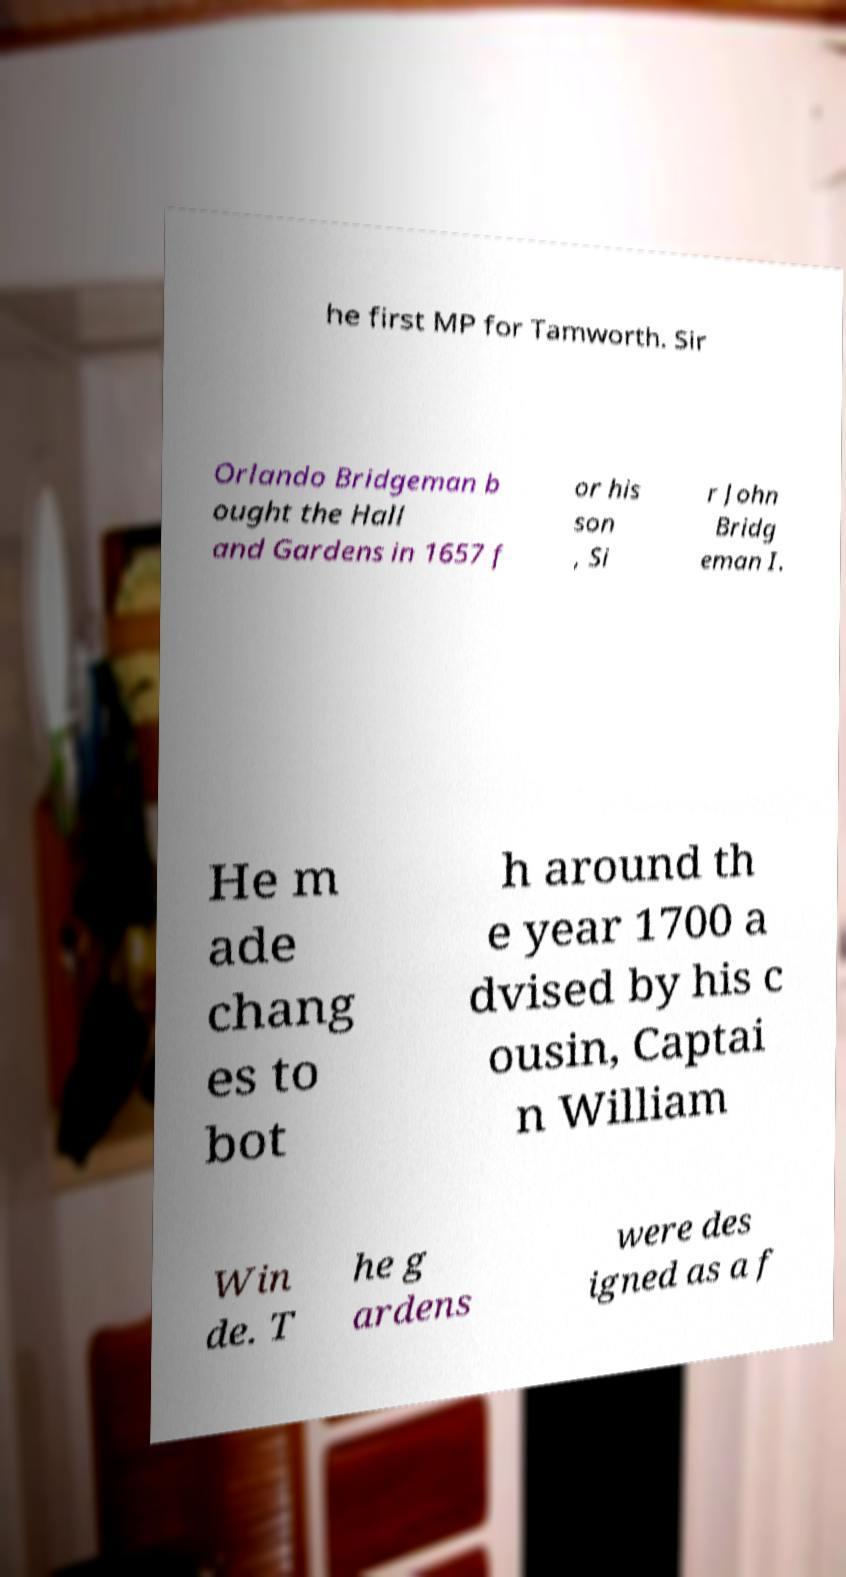Please identify and transcribe the text found in this image. he first MP for Tamworth. Sir Orlando Bridgeman b ought the Hall and Gardens in 1657 f or his son , Si r John Bridg eman I. He m ade chang es to bot h around th e year 1700 a dvised by his c ousin, Captai n William Win de. T he g ardens were des igned as a f 